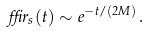<formula> <loc_0><loc_0><loc_500><loc_500>\delta r _ { s } ( t ) \sim e ^ { - t / ( 2 M ) } \, .</formula> 